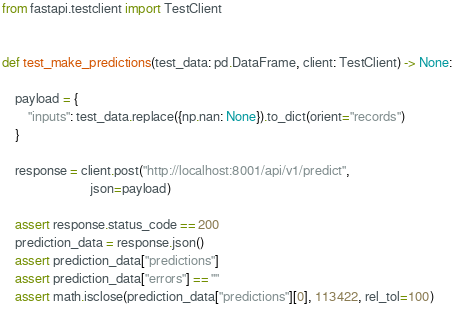Convert code to text. <code><loc_0><loc_0><loc_500><loc_500><_Python_>from fastapi.testclient import TestClient


def test_make_predictions(test_data: pd.DataFrame, client: TestClient) -> None:

    payload = {
        "inputs": test_data.replace({np.nan: None}).to_dict(orient="records")
    }

    response = client.post("http://localhost:8001/api/v1/predict",
                           json=payload)

    assert response.status_code == 200
    prediction_data = response.json()
    assert prediction_data["predictions"]
    assert prediction_data["errors"] == ""
    assert math.isclose(prediction_data["predictions"][0], 113422, rel_tol=100)
</code> 